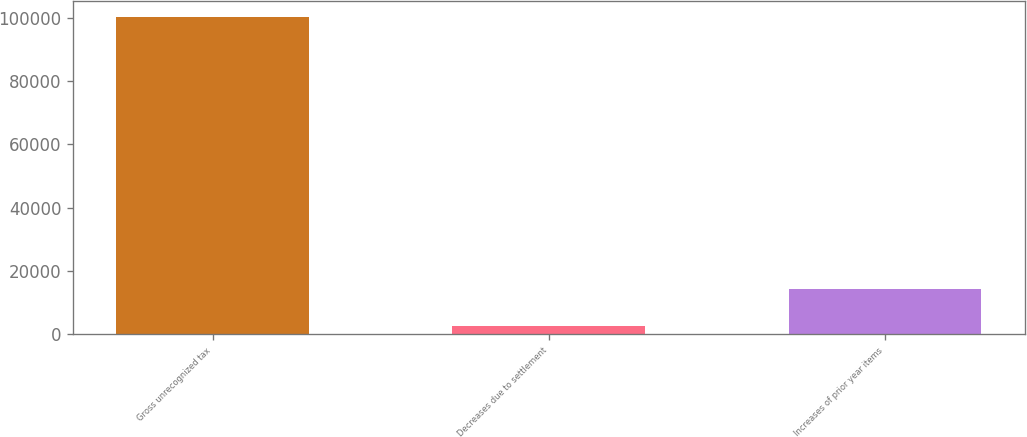Convert chart to OTSL. <chart><loc_0><loc_0><loc_500><loc_500><bar_chart><fcel>Gross unrecognized tax<fcel>Decreases due to settlement<fcel>Increases of prior year items<nl><fcel>100168<fcel>2605<fcel>14213<nl></chart> 